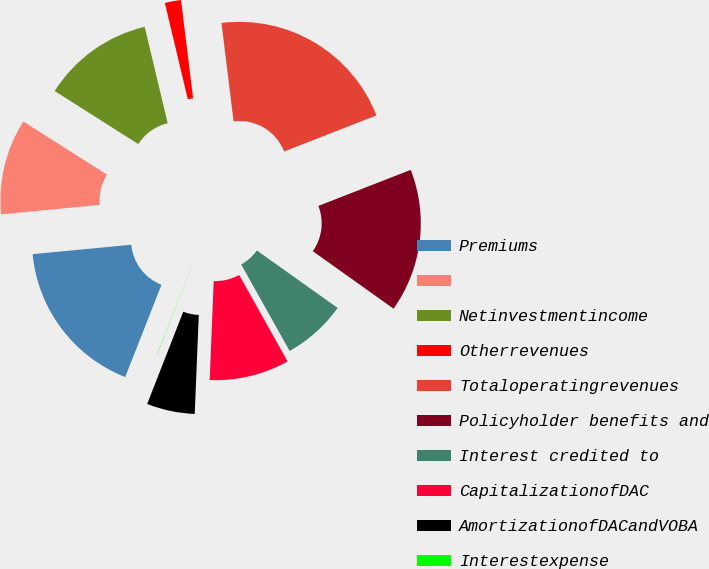Convert chart. <chart><loc_0><loc_0><loc_500><loc_500><pie_chart><fcel>Premiums<fcel>Unnamed: 1<fcel>Netinvestmentincome<fcel>Otherrevenues<fcel>Totaloperatingrevenues<fcel>Policyholder benefits and<fcel>Interest credited to<fcel>CapitalizationofDAC<fcel>AmortizationofDACandVOBA<fcel>Interestexpense<nl><fcel>17.52%<fcel>10.52%<fcel>12.27%<fcel>1.78%<fcel>21.02%<fcel>15.77%<fcel>7.03%<fcel>8.78%<fcel>5.28%<fcel>0.03%<nl></chart> 